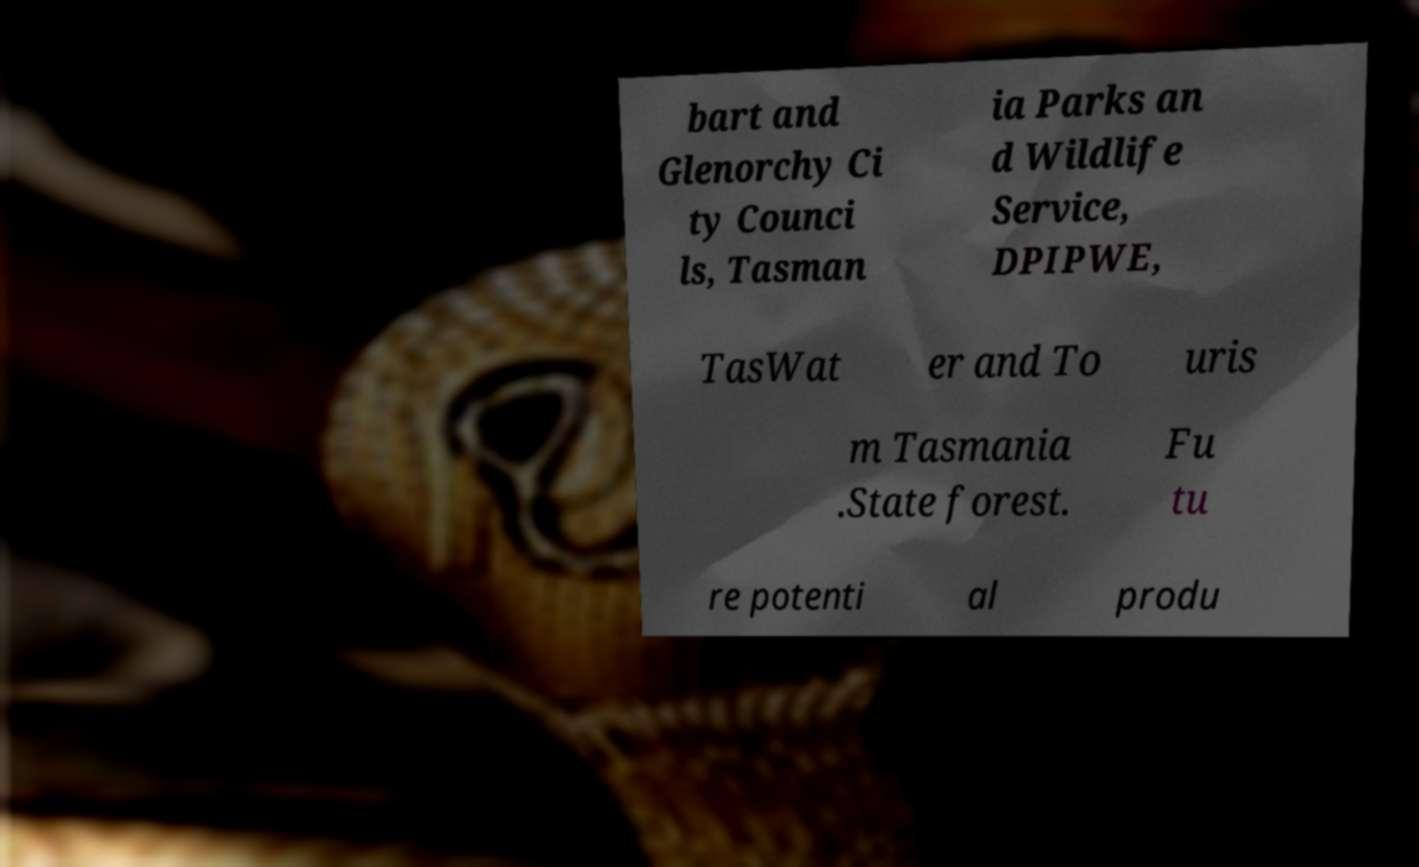Please identify and transcribe the text found in this image. bart and Glenorchy Ci ty Counci ls, Tasman ia Parks an d Wildlife Service, DPIPWE, TasWat er and To uris m Tasmania .State forest. Fu tu re potenti al produ 